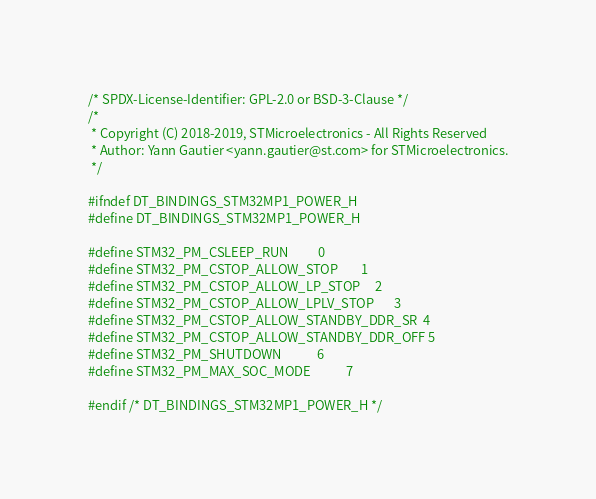Convert code to text. <code><loc_0><loc_0><loc_500><loc_500><_C_>/* SPDX-License-Identifier: GPL-2.0 or BSD-3-Clause */
/*
 * Copyright (C) 2018-2019, STMicroelectronics - All Rights Reserved
 * Author: Yann Gautier <yann.gautier@st.com> for STMicroelectronics.
 */

#ifndef DT_BINDINGS_STM32MP1_POWER_H
#define DT_BINDINGS_STM32MP1_POWER_H

#define STM32_PM_CSLEEP_RUN			0
#define STM32_PM_CSTOP_ALLOW_STOP		1
#define STM32_PM_CSTOP_ALLOW_LP_STOP		2
#define STM32_PM_CSTOP_ALLOW_LPLV_STOP		3
#define STM32_PM_CSTOP_ALLOW_STANDBY_DDR_SR	4
#define STM32_PM_CSTOP_ALLOW_STANDBY_DDR_OFF	5
#define STM32_PM_SHUTDOWN			6
#define STM32_PM_MAX_SOC_MODE			7

#endif /* DT_BINDINGS_STM32MP1_POWER_H */
</code> 